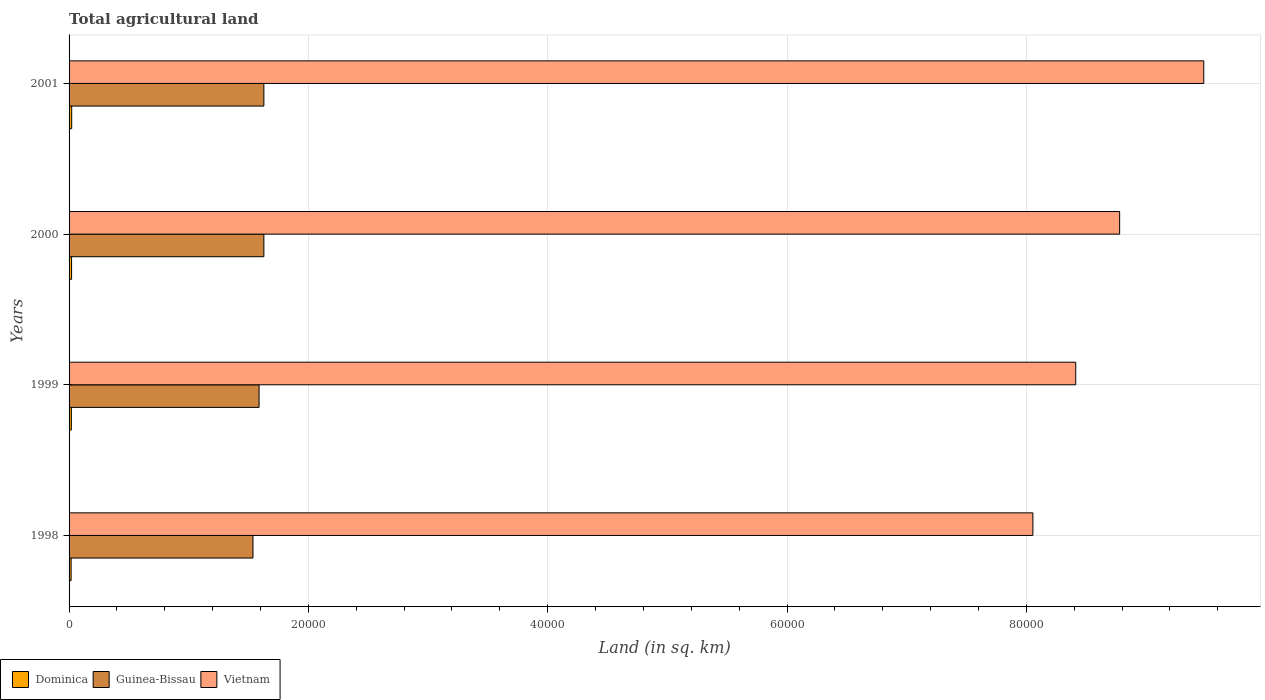How many different coloured bars are there?
Provide a succinct answer. 3. How many bars are there on the 3rd tick from the top?
Your answer should be compact. 3. What is the label of the 4th group of bars from the top?
Your response must be concise. 1998. In how many cases, is the number of bars for a given year not equal to the number of legend labels?
Ensure brevity in your answer.  0. What is the total agricultural land in Dominica in 2001?
Your response must be concise. 220. Across all years, what is the maximum total agricultural land in Vietnam?
Provide a short and direct response. 9.48e+04. Across all years, what is the minimum total agricultural land in Vietnam?
Ensure brevity in your answer.  8.06e+04. In which year was the total agricultural land in Dominica minimum?
Give a very brief answer. 1998. What is the total total agricultural land in Guinea-Bissau in the graph?
Make the answer very short. 6.38e+04. What is the difference between the total agricultural land in Guinea-Bissau in 2001 and the total agricultural land in Vietnam in 1999?
Your response must be concise. -6.78e+04. What is the average total agricultural land in Guinea-Bissau per year?
Ensure brevity in your answer.  1.60e+04. In the year 1999, what is the difference between the total agricultural land in Guinea-Bissau and total agricultural land in Dominica?
Make the answer very short. 1.57e+04. What is the ratio of the total agricultural land in Dominica in 1999 to that in 2001?
Provide a short and direct response. 0.86. Is the total agricultural land in Guinea-Bissau in 1998 less than that in 1999?
Ensure brevity in your answer.  Yes. Is the difference between the total agricultural land in Guinea-Bissau in 2000 and 2001 greater than the difference between the total agricultural land in Dominica in 2000 and 2001?
Your answer should be very brief. Yes. What is the difference between the highest and the second highest total agricultural land in Dominica?
Provide a succinct answer. 10. What is the difference between the highest and the lowest total agricultural land in Dominica?
Give a very brief answer. 50. What does the 2nd bar from the top in 2001 represents?
Your answer should be very brief. Guinea-Bissau. What does the 2nd bar from the bottom in 1999 represents?
Your answer should be very brief. Guinea-Bissau. How many bars are there?
Offer a terse response. 12. How many years are there in the graph?
Offer a terse response. 4. Where does the legend appear in the graph?
Offer a terse response. Bottom left. What is the title of the graph?
Offer a terse response. Total agricultural land. Does "Least developed countries" appear as one of the legend labels in the graph?
Keep it short and to the point. No. What is the label or title of the X-axis?
Make the answer very short. Land (in sq. km). What is the Land (in sq. km) in Dominica in 1998?
Your answer should be compact. 170. What is the Land (in sq. km) in Guinea-Bissau in 1998?
Your response must be concise. 1.54e+04. What is the Land (in sq. km) of Vietnam in 1998?
Your answer should be compact. 8.06e+04. What is the Land (in sq. km) of Dominica in 1999?
Your answer should be very brief. 190. What is the Land (in sq. km) of Guinea-Bissau in 1999?
Provide a succinct answer. 1.59e+04. What is the Land (in sq. km) of Vietnam in 1999?
Give a very brief answer. 8.41e+04. What is the Land (in sq. km) in Dominica in 2000?
Your answer should be compact. 210. What is the Land (in sq. km) in Guinea-Bissau in 2000?
Give a very brief answer. 1.63e+04. What is the Land (in sq. km) in Vietnam in 2000?
Your answer should be compact. 8.78e+04. What is the Land (in sq. km) in Dominica in 2001?
Provide a succinct answer. 220. What is the Land (in sq. km) of Guinea-Bissau in 2001?
Provide a short and direct response. 1.63e+04. What is the Land (in sq. km) of Vietnam in 2001?
Offer a very short reply. 9.48e+04. Across all years, what is the maximum Land (in sq. km) of Dominica?
Provide a succinct answer. 220. Across all years, what is the maximum Land (in sq. km) in Guinea-Bissau?
Your answer should be compact. 1.63e+04. Across all years, what is the maximum Land (in sq. km) of Vietnam?
Give a very brief answer. 9.48e+04. Across all years, what is the minimum Land (in sq. km) of Dominica?
Make the answer very short. 170. Across all years, what is the minimum Land (in sq. km) in Guinea-Bissau?
Provide a short and direct response. 1.54e+04. Across all years, what is the minimum Land (in sq. km) of Vietnam?
Keep it short and to the point. 8.06e+04. What is the total Land (in sq. km) of Dominica in the graph?
Ensure brevity in your answer.  790. What is the total Land (in sq. km) in Guinea-Bissau in the graph?
Your response must be concise. 6.38e+04. What is the total Land (in sq. km) of Vietnam in the graph?
Make the answer very short. 3.47e+05. What is the difference between the Land (in sq. km) of Dominica in 1998 and that in 1999?
Your answer should be compact. -20. What is the difference between the Land (in sq. km) of Guinea-Bissau in 1998 and that in 1999?
Offer a terse response. -510. What is the difference between the Land (in sq. km) in Vietnam in 1998 and that in 1999?
Offer a very short reply. -3580. What is the difference between the Land (in sq. km) in Guinea-Bissau in 1998 and that in 2000?
Make the answer very short. -910. What is the difference between the Land (in sq. km) of Vietnam in 1998 and that in 2000?
Offer a terse response. -7250. What is the difference between the Land (in sq. km) of Dominica in 1998 and that in 2001?
Provide a short and direct response. -50. What is the difference between the Land (in sq. km) in Guinea-Bissau in 1998 and that in 2001?
Your answer should be very brief. -910. What is the difference between the Land (in sq. km) in Vietnam in 1998 and that in 2001?
Offer a very short reply. -1.43e+04. What is the difference between the Land (in sq. km) in Guinea-Bissau in 1999 and that in 2000?
Give a very brief answer. -400. What is the difference between the Land (in sq. km) of Vietnam in 1999 and that in 2000?
Offer a very short reply. -3670. What is the difference between the Land (in sq. km) of Guinea-Bissau in 1999 and that in 2001?
Provide a short and direct response. -400. What is the difference between the Land (in sq. km) in Vietnam in 1999 and that in 2001?
Offer a terse response. -1.07e+04. What is the difference between the Land (in sq. km) in Vietnam in 2000 and that in 2001?
Ensure brevity in your answer.  -7030. What is the difference between the Land (in sq. km) in Dominica in 1998 and the Land (in sq. km) in Guinea-Bissau in 1999?
Make the answer very short. -1.57e+04. What is the difference between the Land (in sq. km) in Dominica in 1998 and the Land (in sq. km) in Vietnam in 1999?
Provide a succinct answer. -8.40e+04. What is the difference between the Land (in sq. km) of Guinea-Bissau in 1998 and the Land (in sq. km) of Vietnam in 1999?
Offer a terse response. -6.88e+04. What is the difference between the Land (in sq. km) in Dominica in 1998 and the Land (in sq. km) in Guinea-Bissau in 2000?
Give a very brief answer. -1.61e+04. What is the difference between the Land (in sq. km) of Dominica in 1998 and the Land (in sq. km) of Vietnam in 2000?
Provide a short and direct response. -8.76e+04. What is the difference between the Land (in sq. km) of Guinea-Bissau in 1998 and the Land (in sq. km) of Vietnam in 2000?
Your answer should be compact. -7.24e+04. What is the difference between the Land (in sq. km) of Dominica in 1998 and the Land (in sq. km) of Guinea-Bissau in 2001?
Keep it short and to the point. -1.61e+04. What is the difference between the Land (in sq. km) in Dominica in 1998 and the Land (in sq. km) in Vietnam in 2001?
Give a very brief answer. -9.47e+04. What is the difference between the Land (in sq. km) of Guinea-Bissau in 1998 and the Land (in sq. km) of Vietnam in 2001?
Offer a very short reply. -7.95e+04. What is the difference between the Land (in sq. km) of Dominica in 1999 and the Land (in sq. km) of Guinea-Bissau in 2000?
Keep it short and to the point. -1.61e+04. What is the difference between the Land (in sq. km) in Dominica in 1999 and the Land (in sq. km) in Vietnam in 2000?
Your answer should be very brief. -8.76e+04. What is the difference between the Land (in sq. km) of Guinea-Bissau in 1999 and the Land (in sq. km) of Vietnam in 2000?
Provide a succinct answer. -7.19e+04. What is the difference between the Land (in sq. km) of Dominica in 1999 and the Land (in sq. km) of Guinea-Bissau in 2001?
Your answer should be compact. -1.61e+04. What is the difference between the Land (in sq. km) of Dominica in 1999 and the Land (in sq. km) of Vietnam in 2001?
Offer a very short reply. -9.46e+04. What is the difference between the Land (in sq. km) of Guinea-Bissau in 1999 and the Land (in sq. km) of Vietnam in 2001?
Your answer should be compact. -7.90e+04. What is the difference between the Land (in sq. km) in Dominica in 2000 and the Land (in sq. km) in Guinea-Bissau in 2001?
Your answer should be compact. -1.61e+04. What is the difference between the Land (in sq. km) in Dominica in 2000 and the Land (in sq. km) in Vietnam in 2001?
Offer a very short reply. -9.46e+04. What is the difference between the Land (in sq. km) in Guinea-Bissau in 2000 and the Land (in sq. km) in Vietnam in 2001?
Your answer should be very brief. -7.86e+04. What is the average Land (in sq. km) of Dominica per year?
Your answer should be compact. 197.5. What is the average Land (in sq. km) of Guinea-Bissau per year?
Provide a short and direct response. 1.60e+04. What is the average Land (in sq. km) in Vietnam per year?
Offer a very short reply. 8.68e+04. In the year 1998, what is the difference between the Land (in sq. km) of Dominica and Land (in sq. km) of Guinea-Bissau?
Your response must be concise. -1.52e+04. In the year 1998, what is the difference between the Land (in sq. km) in Dominica and Land (in sq. km) in Vietnam?
Ensure brevity in your answer.  -8.04e+04. In the year 1998, what is the difference between the Land (in sq. km) in Guinea-Bissau and Land (in sq. km) in Vietnam?
Keep it short and to the point. -6.52e+04. In the year 1999, what is the difference between the Land (in sq. km) in Dominica and Land (in sq. km) in Guinea-Bissau?
Your answer should be very brief. -1.57e+04. In the year 1999, what is the difference between the Land (in sq. km) in Dominica and Land (in sq. km) in Vietnam?
Your answer should be compact. -8.39e+04. In the year 1999, what is the difference between the Land (in sq. km) of Guinea-Bissau and Land (in sq. km) of Vietnam?
Offer a very short reply. -6.82e+04. In the year 2000, what is the difference between the Land (in sq. km) of Dominica and Land (in sq. km) of Guinea-Bissau?
Keep it short and to the point. -1.61e+04. In the year 2000, what is the difference between the Land (in sq. km) in Dominica and Land (in sq. km) in Vietnam?
Give a very brief answer. -8.76e+04. In the year 2000, what is the difference between the Land (in sq. km) of Guinea-Bissau and Land (in sq. km) of Vietnam?
Provide a short and direct response. -7.15e+04. In the year 2001, what is the difference between the Land (in sq. km) in Dominica and Land (in sq. km) in Guinea-Bissau?
Provide a succinct answer. -1.61e+04. In the year 2001, what is the difference between the Land (in sq. km) in Dominica and Land (in sq. km) in Vietnam?
Offer a terse response. -9.46e+04. In the year 2001, what is the difference between the Land (in sq. km) of Guinea-Bissau and Land (in sq. km) of Vietnam?
Ensure brevity in your answer.  -7.86e+04. What is the ratio of the Land (in sq. km) of Dominica in 1998 to that in 1999?
Your response must be concise. 0.89. What is the ratio of the Land (in sq. km) of Guinea-Bissau in 1998 to that in 1999?
Keep it short and to the point. 0.97. What is the ratio of the Land (in sq. km) in Vietnam in 1998 to that in 1999?
Your response must be concise. 0.96. What is the ratio of the Land (in sq. km) of Dominica in 1998 to that in 2000?
Provide a succinct answer. 0.81. What is the ratio of the Land (in sq. km) of Guinea-Bissau in 1998 to that in 2000?
Keep it short and to the point. 0.94. What is the ratio of the Land (in sq. km) of Vietnam in 1998 to that in 2000?
Offer a terse response. 0.92. What is the ratio of the Land (in sq. km) in Dominica in 1998 to that in 2001?
Offer a very short reply. 0.77. What is the ratio of the Land (in sq. km) of Guinea-Bissau in 1998 to that in 2001?
Keep it short and to the point. 0.94. What is the ratio of the Land (in sq. km) of Vietnam in 1998 to that in 2001?
Give a very brief answer. 0.85. What is the ratio of the Land (in sq. km) in Dominica in 1999 to that in 2000?
Provide a succinct answer. 0.9. What is the ratio of the Land (in sq. km) of Guinea-Bissau in 1999 to that in 2000?
Your answer should be compact. 0.98. What is the ratio of the Land (in sq. km) in Vietnam in 1999 to that in 2000?
Your answer should be very brief. 0.96. What is the ratio of the Land (in sq. km) in Dominica in 1999 to that in 2001?
Your answer should be compact. 0.86. What is the ratio of the Land (in sq. km) of Guinea-Bissau in 1999 to that in 2001?
Give a very brief answer. 0.98. What is the ratio of the Land (in sq. km) in Vietnam in 1999 to that in 2001?
Your response must be concise. 0.89. What is the ratio of the Land (in sq. km) in Dominica in 2000 to that in 2001?
Keep it short and to the point. 0.95. What is the ratio of the Land (in sq. km) in Vietnam in 2000 to that in 2001?
Provide a short and direct response. 0.93. What is the difference between the highest and the second highest Land (in sq. km) in Vietnam?
Keep it short and to the point. 7030. What is the difference between the highest and the lowest Land (in sq. km) of Dominica?
Provide a short and direct response. 50. What is the difference between the highest and the lowest Land (in sq. km) in Guinea-Bissau?
Provide a succinct answer. 910. What is the difference between the highest and the lowest Land (in sq. km) in Vietnam?
Give a very brief answer. 1.43e+04. 